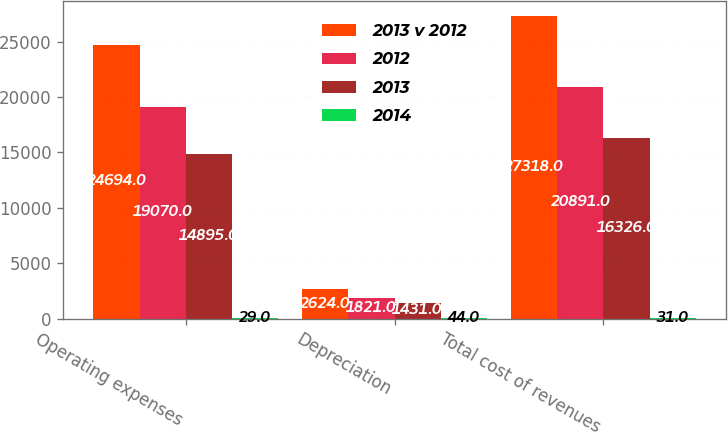Convert chart. <chart><loc_0><loc_0><loc_500><loc_500><stacked_bar_chart><ecel><fcel>Operating expenses<fcel>Depreciation<fcel>Total cost of revenues<nl><fcel>2013 v 2012<fcel>24694<fcel>2624<fcel>27318<nl><fcel>2012<fcel>19070<fcel>1821<fcel>20891<nl><fcel>2013<fcel>14895<fcel>1431<fcel>16326<nl><fcel>2014<fcel>29<fcel>44<fcel>31<nl></chart> 